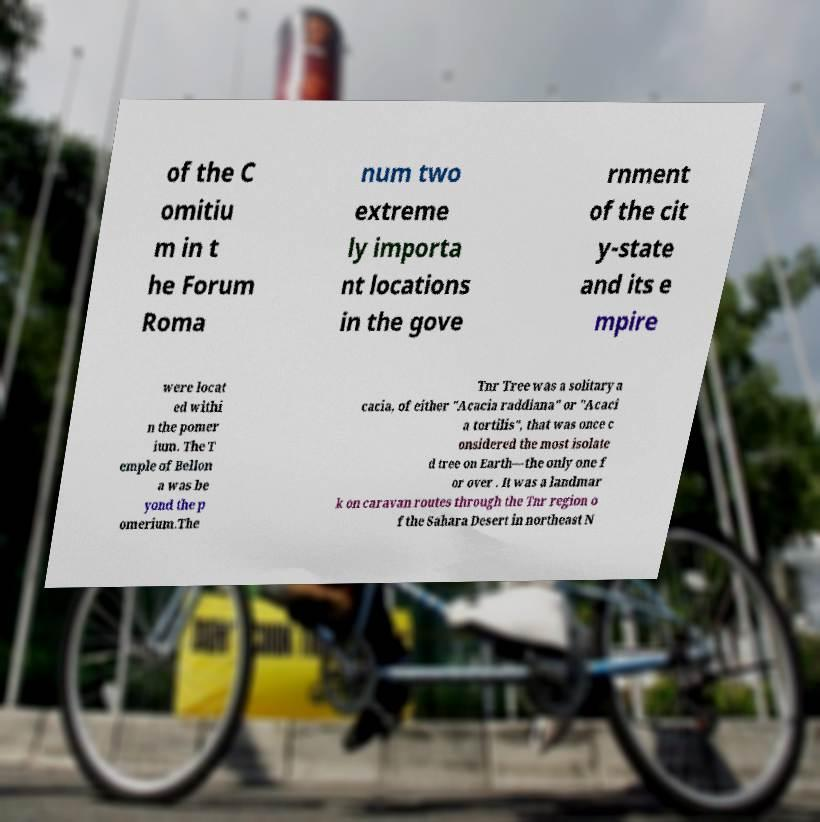I need the written content from this picture converted into text. Can you do that? of the C omitiu m in t he Forum Roma num two extreme ly importa nt locations in the gove rnment of the cit y-state and its e mpire were locat ed withi n the pomer ium. The T emple of Bellon a was be yond the p omerium.The Tnr Tree was a solitary a cacia, of either "Acacia raddiana" or "Acaci a tortilis", that was once c onsidered the most isolate d tree on Earth—the only one f or over . It was a landmar k on caravan routes through the Tnr region o f the Sahara Desert in northeast N 